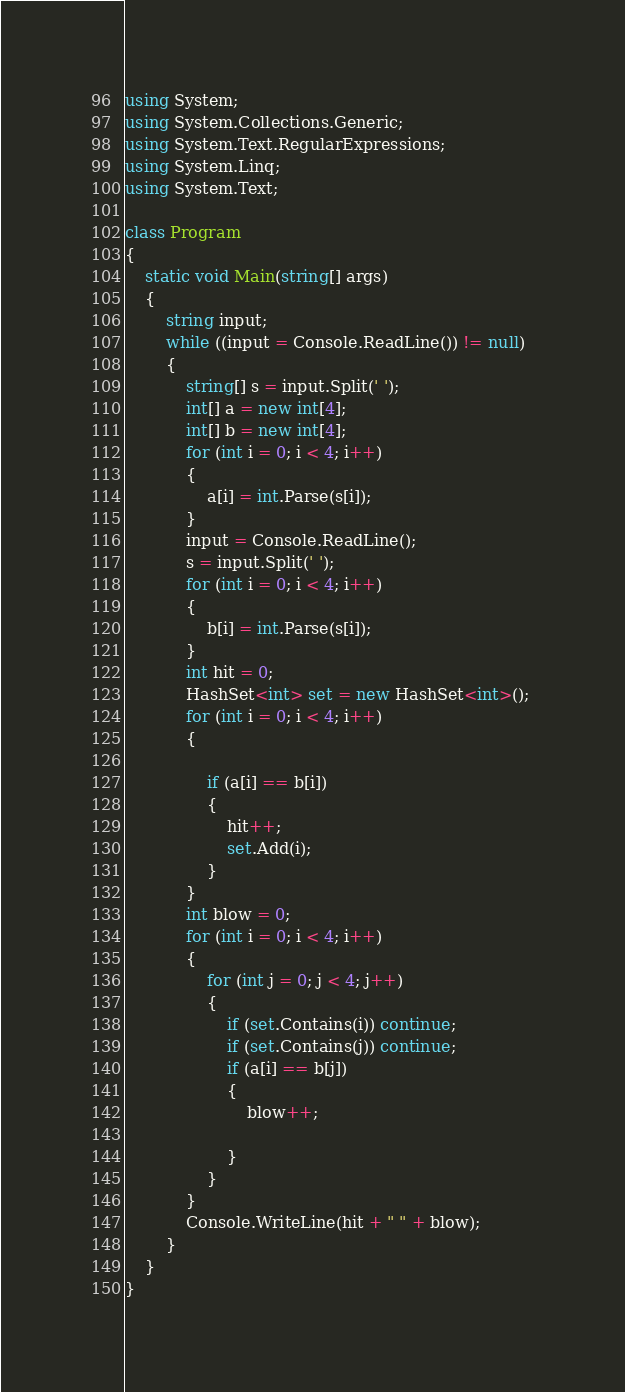Convert code to text. <code><loc_0><loc_0><loc_500><loc_500><_C#_>using System;
using System.Collections.Generic;
using System.Text.RegularExpressions;
using System.Linq;
using System.Text;

class Program
{
    static void Main(string[] args)
    {
        string input;
        while ((input = Console.ReadLine()) != null)
        {
            string[] s = input.Split(' ');
            int[] a = new int[4];
            int[] b = new int[4];
            for (int i = 0; i < 4; i++)
            {
                a[i] = int.Parse(s[i]);
            }
            input = Console.ReadLine();
            s = input.Split(' ');
            for (int i = 0; i < 4; i++)
            {
                b[i] = int.Parse(s[i]);
            }
            int hit = 0;
            HashSet<int> set = new HashSet<int>(); 
            for (int i = 0; i < 4; i++)
            {

                if (a[i] == b[i])
                {
                    hit++;
                    set.Add(i);
                }
            }
            int blow = 0;
            for (int i = 0; i < 4; i++)
            {
                for (int j = 0; j < 4; j++)
                {
                    if (set.Contains(i)) continue;
                    if (set.Contains(j)) continue;
                    if (a[i] == b[j])
                    {
                        blow++;
                        
                    }
                }
            }
            Console.WriteLine(hit + " " + blow);
        }
    }
}</code> 